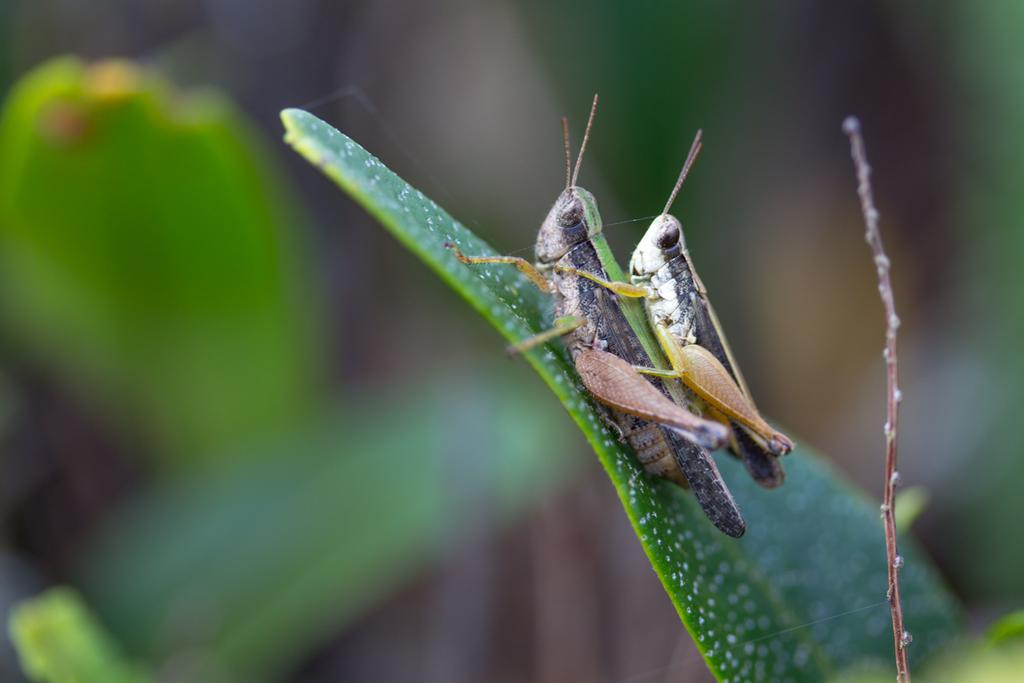What is present on the leaf in the image? There is a grasshopper on the leaf in the image. Can you describe the position of the grasshoppers in relation to each other? There is another grasshopper above the first grasshopper. What can be observed about the background of the image? The background of the image is blurred. What type of cream is being tested in the image? There is no cream or testing activity present in the image. What word is written on the leaf in the image? There are no words written on the leaf in the image; it only has a grasshopper on it. 